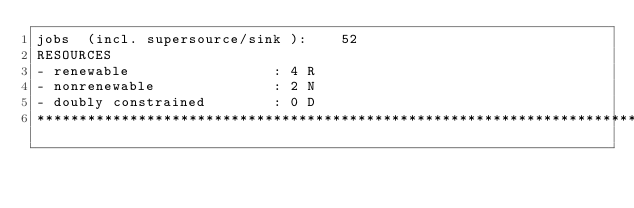Convert code to text. <code><loc_0><loc_0><loc_500><loc_500><_ObjectiveC_>jobs  (incl. supersource/sink ):	52
RESOURCES
- renewable                 : 4 R
- nonrenewable              : 2 N
- doubly constrained        : 0 D
************************************************************************</code> 